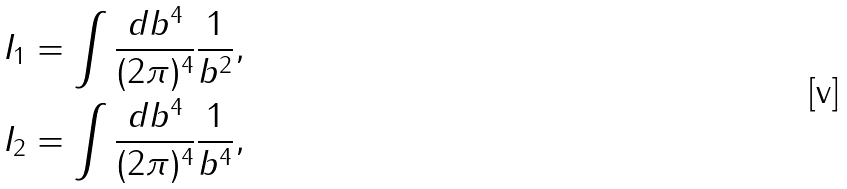<formula> <loc_0><loc_0><loc_500><loc_500>I _ { 1 } & = \int \frac { d b ^ { 4 } } { ( 2 \pi ) ^ { 4 } } \frac { 1 } { b ^ { 2 } } , \\ I _ { 2 } & = \int \frac { d b ^ { 4 } } { ( 2 \pi ) ^ { 4 } } \frac { 1 } { b ^ { 4 } } ,</formula> 